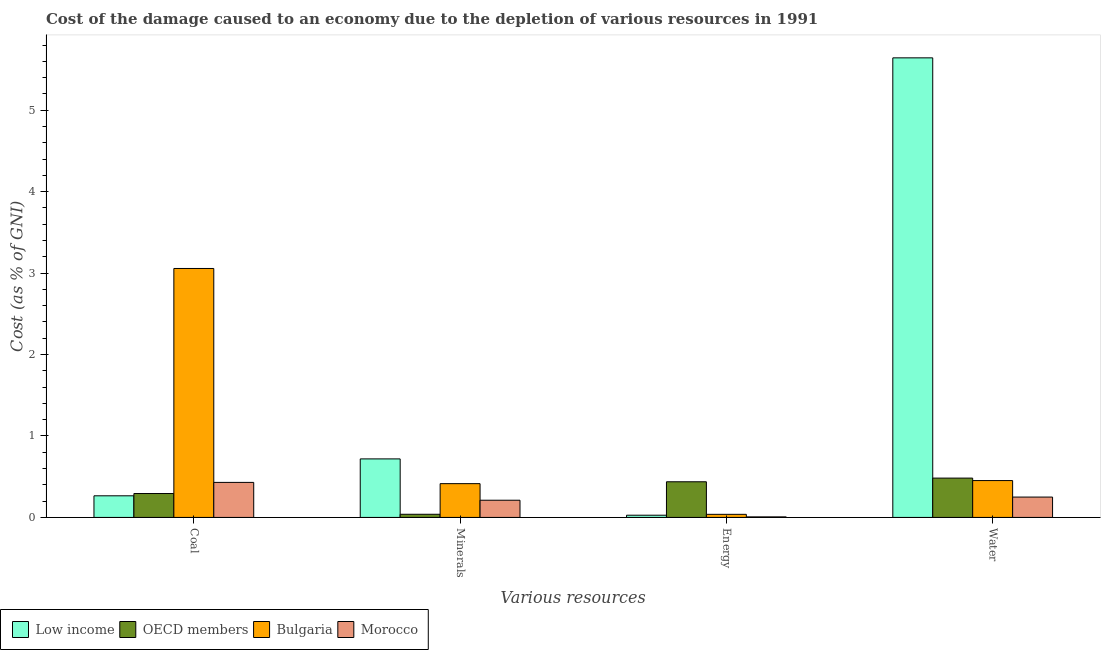How many groups of bars are there?
Give a very brief answer. 4. Are the number of bars per tick equal to the number of legend labels?
Provide a short and direct response. Yes. Are the number of bars on each tick of the X-axis equal?
Keep it short and to the point. Yes. How many bars are there on the 2nd tick from the left?
Provide a short and direct response. 4. What is the label of the 2nd group of bars from the left?
Make the answer very short. Minerals. What is the cost of damage due to depletion of energy in Bulgaria?
Provide a short and direct response. 0.04. Across all countries, what is the maximum cost of damage due to depletion of energy?
Make the answer very short. 0.44. Across all countries, what is the minimum cost of damage due to depletion of minerals?
Your answer should be very brief. 0.04. In which country was the cost of damage due to depletion of energy maximum?
Provide a short and direct response. OECD members. What is the total cost of damage due to depletion of coal in the graph?
Ensure brevity in your answer.  4.05. What is the difference between the cost of damage due to depletion of coal in OECD members and that in Bulgaria?
Give a very brief answer. -2.76. What is the difference between the cost of damage due to depletion of coal in Low income and the cost of damage due to depletion of water in Morocco?
Provide a short and direct response. 0.02. What is the average cost of damage due to depletion of energy per country?
Keep it short and to the point. 0.13. What is the difference between the cost of damage due to depletion of energy and cost of damage due to depletion of water in Morocco?
Offer a very short reply. -0.24. What is the ratio of the cost of damage due to depletion of minerals in Morocco to that in OECD members?
Offer a terse response. 5.46. Is the cost of damage due to depletion of minerals in OECD members less than that in Morocco?
Provide a succinct answer. Yes. What is the difference between the highest and the second highest cost of damage due to depletion of energy?
Your answer should be compact. 0.4. What is the difference between the highest and the lowest cost of damage due to depletion of energy?
Offer a very short reply. 0.43. Is the sum of the cost of damage due to depletion of energy in Low income and Bulgaria greater than the maximum cost of damage due to depletion of coal across all countries?
Give a very brief answer. No. What does the 4th bar from the left in Water represents?
Give a very brief answer. Morocco. What does the 2nd bar from the right in Coal represents?
Offer a very short reply. Bulgaria. Is it the case that in every country, the sum of the cost of damage due to depletion of coal and cost of damage due to depletion of minerals is greater than the cost of damage due to depletion of energy?
Make the answer very short. No. How many bars are there?
Make the answer very short. 16. How many countries are there in the graph?
Provide a succinct answer. 4. What is the difference between two consecutive major ticks on the Y-axis?
Make the answer very short. 1. Are the values on the major ticks of Y-axis written in scientific E-notation?
Ensure brevity in your answer.  No. How many legend labels are there?
Give a very brief answer. 4. How are the legend labels stacked?
Your answer should be compact. Horizontal. What is the title of the graph?
Your response must be concise. Cost of the damage caused to an economy due to the depletion of various resources in 1991 . What is the label or title of the X-axis?
Ensure brevity in your answer.  Various resources. What is the label or title of the Y-axis?
Make the answer very short. Cost (as % of GNI). What is the Cost (as % of GNI) in Low income in Coal?
Provide a short and direct response. 0.27. What is the Cost (as % of GNI) in OECD members in Coal?
Make the answer very short. 0.29. What is the Cost (as % of GNI) of Bulgaria in Coal?
Provide a succinct answer. 3.06. What is the Cost (as % of GNI) of Morocco in Coal?
Offer a very short reply. 0.43. What is the Cost (as % of GNI) of Low income in Minerals?
Offer a terse response. 0.72. What is the Cost (as % of GNI) of OECD members in Minerals?
Offer a very short reply. 0.04. What is the Cost (as % of GNI) of Bulgaria in Minerals?
Keep it short and to the point. 0.41. What is the Cost (as % of GNI) in Morocco in Minerals?
Give a very brief answer. 0.21. What is the Cost (as % of GNI) of Low income in Energy?
Your answer should be very brief. 0.03. What is the Cost (as % of GNI) of OECD members in Energy?
Offer a very short reply. 0.44. What is the Cost (as % of GNI) in Bulgaria in Energy?
Your answer should be compact. 0.04. What is the Cost (as % of GNI) of Morocco in Energy?
Your answer should be very brief. 0.01. What is the Cost (as % of GNI) of Low income in Water?
Keep it short and to the point. 5.64. What is the Cost (as % of GNI) of OECD members in Water?
Your answer should be compact. 0.48. What is the Cost (as % of GNI) in Bulgaria in Water?
Provide a succinct answer. 0.45. What is the Cost (as % of GNI) of Morocco in Water?
Ensure brevity in your answer.  0.25. Across all Various resources, what is the maximum Cost (as % of GNI) of Low income?
Provide a succinct answer. 5.64. Across all Various resources, what is the maximum Cost (as % of GNI) of OECD members?
Give a very brief answer. 0.48. Across all Various resources, what is the maximum Cost (as % of GNI) of Bulgaria?
Ensure brevity in your answer.  3.06. Across all Various resources, what is the maximum Cost (as % of GNI) in Morocco?
Your answer should be compact. 0.43. Across all Various resources, what is the minimum Cost (as % of GNI) in Low income?
Offer a terse response. 0.03. Across all Various resources, what is the minimum Cost (as % of GNI) in OECD members?
Provide a short and direct response. 0.04. Across all Various resources, what is the minimum Cost (as % of GNI) of Bulgaria?
Keep it short and to the point. 0.04. Across all Various resources, what is the minimum Cost (as % of GNI) of Morocco?
Give a very brief answer. 0.01. What is the total Cost (as % of GNI) in Low income in the graph?
Your answer should be compact. 6.65. What is the total Cost (as % of GNI) in OECD members in the graph?
Ensure brevity in your answer.  1.25. What is the total Cost (as % of GNI) in Bulgaria in the graph?
Your answer should be very brief. 3.96. What is the total Cost (as % of GNI) in Morocco in the graph?
Provide a succinct answer. 0.9. What is the difference between the Cost (as % of GNI) of Low income in Coal and that in Minerals?
Give a very brief answer. -0.45. What is the difference between the Cost (as % of GNI) of OECD members in Coal and that in Minerals?
Your answer should be compact. 0.25. What is the difference between the Cost (as % of GNI) of Bulgaria in Coal and that in Minerals?
Give a very brief answer. 2.64. What is the difference between the Cost (as % of GNI) of Morocco in Coal and that in Minerals?
Provide a short and direct response. 0.22. What is the difference between the Cost (as % of GNI) in Low income in Coal and that in Energy?
Offer a terse response. 0.24. What is the difference between the Cost (as % of GNI) of OECD members in Coal and that in Energy?
Your answer should be compact. -0.14. What is the difference between the Cost (as % of GNI) in Bulgaria in Coal and that in Energy?
Keep it short and to the point. 3.02. What is the difference between the Cost (as % of GNI) of Morocco in Coal and that in Energy?
Your response must be concise. 0.42. What is the difference between the Cost (as % of GNI) in Low income in Coal and that in Water?
Offer a terse response. -5.38. What is the difference between the Cost (as % of GNI) in OECD members in Coal and that in Water?
Ensure brevity in your answer.  -0.19. What is the difference between the Cost (as % of GNI) of Bulgaria in Coal and that in Water?
Your response must be concise. 2.6. What is the difference between the Cost (as % of GNI) in Morocco in Coal and that in Water?
Keep it short and to the point. 0.18. What is the difference between the Cost (as % of GNI) in Low income in Minerals and that in Energy?
Make the answer very short. 0.69. What is the difference between the Cost (as % of GNI) of OECD members in Minerals and that in Energy?
Offer a terse response. -0.4. What is the difference between the Cost (as % of GNI) in Bulgaria in Minerals and that in Energy?
Provide a short and direct response. 0.38. What is the difference between the Cost (as % of GNI) in Morocco in Minerals and that in Energy?
Provide a short and direct response. 0.2. What is the difference between the Cost (as % of GNI) in Low income in Minerals and that in Water?
Your answer should be compact. -4.92. What is the difference between the Cost (as % of GNI) in OECD members in Minerals and that in Water?
Your answer should be very brief. -0.44. What is the difference between the Cost (as % of GNI) in Bulgaria in Minerals and that in Water?
Keep it short and to the point. -0.04. What is the difference between the Cost (as % of GNI) of Morocco in Minerals and that in Water?
Offer a terse response. -0.04. What is the difference between the Cost (as % of GNI) in Low income in Energy and that in Water?
Your answer should be very brief. -5.62. What is the difference between the Cost (as % of GNI) of OECD members in Energy and that in Water?
Give a very brief answer. -0.05. What is the difference between the Cost (as % of GNI) of Bulgaria in Energy and that in Water?
Your response must be concise. -0.41. What is the difference between the Cost (as % of GNI) in Morocco in Energy and that in Water?
Offer a terse response. -0.24. What is the difference between the Cost (as % of GNI) of Low income in Coal and the Cost (as % of GNI) of OECD members in Minerals?
Keep it short and to the point. 0.23. What is the difference between the Cost (as % of GNI) in Low income in Coal and the Cost (as % of GNI) in Bulgaria in Minerals?
Give a very brief answer. -0.15. What is the difference between the Cost (as % of GNI) in Low income in Coal and the Cost (as % of GNI) in Morocco in Minerals?
Keep it short and to the point. 0.05. What is the difference between the Cost (as % of GNI) in OECD members in Coal and the Cost (as % of GNI) in Bulgaria in Minerals?
Your answer should be very brief. -0.12. What is the difference between the Cost (as % of GNI) in OECD members in Coal and the Cost (as % of GNI) in Morocco in Minerals?
Your answer should be very brief. 0.08. What is the difference between the Cost (as % of GNI) in Bulgaria in Coal and the Cost (as % of GNI) in Morocco in Minerals?
Ensure brevity in your answer.  2.85. What is the difference between the Cost (as % of GNI) of Low income in Coal and the Cost (as % of GNI) of OECD members in Energy?
Your answer should be compact. -0.17. What is the difference between the Cost (as % of GNI) of Low income in Coal and the Cost (as % of GNI) of Bulgaria in Energy?
Keep it short and to the point. 0.23. What is the difference between the Cost (as % of GNI) of Low income in Coal and the Cost (as % of GNI) of Morocco in Energy?
Your answer should be very brief. 0.26. What is the difference between the Cost (as % of GNI) in OECD members in Coal and the Cost (as % of GNI) in Bulgaria in Energy?
Your answer should be compact. 0.26. What is the difference between the Cost (as % of GNI) in OECD members in Coal and the Cost (as % of GNI) in Morocco in Energy?
Give a very brief answer. 0.29. What is the difference between the Cost (as % of GNI) of Bulgaria in Coal and the Cost (as % of GNI) of Morocco in Energy?
Provide a short and direct response. 3.05. What is the difference between the Cost (as % of GNI) of Low income in Coal and the Cost (as % of GNI) of OECD members in Water?
Make the answer very short. -0.22. What is the difference between the Cost (as % of GNI) of Low income in Coal and the Cost (as % of GNI) of Bulgaria in Water?
Make the answer very short. -0.19. What is the difference between the Cost (as % of GNI) in Low income in Coal and the Cost (as % of GNI) in Morocco in Water?
Your answer should be very brief. 0.02. What is the difference between the Cost (as % of GNI) of OECD members in Coal and the Cost (as % of GNI) of Bulgaria in Water?
Provide a short and direct response. -0.16. What is the difference between the Cost (as % of GNI) of OECD members in Coal and the Cost (as % of GNI) of Morocco in Water?
Offer a terse response. 0.04. What is the difference between the Cost (as % of GNI) of Bulgaria in Coal and the Cost (as % of GNI) of Morocco in Water?
Provide a short and direct response. 2.81. What is the difference between the Cost (as % of GNI) of Low income in Minerals and the Cost (as % of GNI) of OECD members in Energy?
Make the answer very short. 0.28. What is the difference between the Cost (as % of GNI) of Low income in Minerals and the Cost (as % of GNI) of Bulgaria in Energy?
Your answer should be very brief. 0.68. What is the difference between the Cost (as % of GNI) of Low income in Minerals and the Cost (as % of GNI) of Morocco in Energy?
Ensure brevity in your answer.  0.71. What is the difference between the Cost (as % of GNI) in OECD members in Minerals and the Cost (as % of GNI) in Bulgaria in Energy?
Keep it short and to the point. 0. What is the difference between the Cost (as % of GNI) in OECD members in Minerals and the Cost (as % of GNI) in Morocco in Energy?
Provide a succinct answer. 0.03. What is the difference between the Cost (as % of GNI) of Bulgaria in Minerals and the Cost (as % of GNI) of Morocco in Energy?
Your response must be concise. 0.41. What is the difference between the Cost (as % of GNI) in Low income in Minerals and the Cost (as % of GNI) in OECD members in Water?
Provide a short and direct response. 0.24. What is the difference between the Cost (as % of GNI) in Low income in Minerals and the Cost (as % of GNI) in Bulgaria in Water?
Offer a very short reply. 0.27. What is the difference between the Cost (as % of GNI) of Low income in Minerals and the Cost (as % of GNI) of Morocco in Water?
Your response must be concise. 0.47. What is the difference between the Cost (as % of GNI) in OECD members in Minerals and the Cost (as % of GNI) in Bulgaria in Water?
Your answer should be compact. -0.41. What is the difference between the Cost (as % of GNI) in OECD members in Minerals and the Cost (as % of GNI) in Morocco in Water?
Make the answer very short. -0.21. What is the difference between the Cost (as % of GNI) of Bulgaria in Minerals and the Cost (as % of GNI) of Morocco in Water?
Offer a terse response. 0.16. What is the difference between the Cost (as % of GNI) in Low income in Energy and the Cost (as % of GNI) in OECD members in Water?
Your response must be concise. -0.46. What is the difference between the Cost (as % of GNI) in Low income in Energy and the Cost (as % of GNI) in Bulgaria in Water?
Offer a very short reply. -0.43. What is the difference between the Cost (as % of GNI) in Low income in Energy and the Cost (as % of GNI) in Morocco in Water?
Provide a short and direct response. -0.22. What is the difference between the Cost (as % of GNI) of OECD members in Energy and the Cost (as % of GNI) of Bulgaria in Water?
Offer a very short reply. -0.01. What is the difference between the Cost (as % of GNI) of OECD members in Energy and the Cost (as % of GNI) of Morocco in Water?
Ensure brevity in your answer.  0.19. What is the difference between the Cost (as % of GNI) of Bulgaria in Energy and the Cost (as % of GNI) of Morocco in Water?
Offer a very short reply. -0.21. What is the average Cost (as % of GNI) in Low income per Various resources?
Offer a terse response. 1.66. What is the average Cost (as % of GNI) of OECD members per Various resources?
Your answer should be compact. 0.31. What is the average Cost (as % of GNI) in Bulgaria per Various resources?
Provide a short and direct response. 0.99. What is the average Cost (as % of GNI) in Morocco per Various resources?
Make the answer very short. 0.22. What is the difference between the Cost (as % of GNI) in Low income and Cost (as % of GNI) in OECD members in Coal?
Provide a short and direct response. -0.03. What is the difference between the Cost (as % of GNI) in Low income and Cost (as % of GNI) in Bulgaria in Coal?
Your response must be concise. -2.79. What is the difference between the Cost (as % of GNI) of Low income and Cost (as % of GNI) of Morocco in Coal?
Your answer should be compact. -0.16. What is the difference between the Cost (as % of GNI) of OECD members and Cost (as % of GNI) of Bulgaria in Coal?
Provide a succinct answer. -2.76. What is the difference between the Cost (as % of GNI) of OECD members and Cost (as % of GNI) of Morocco in Coal?
Give a very brief answer. -0.14. What is the difference between the Cost (as % of GNI) in Bulgaria and Cost (as % of GNI) in Morocco in Coal?
Keep it short and to the point. 2.63. What is the difference between the Cost (as % of GNI) in Low income and Cost (as % of GNI) in OECD members in Minerals?
Offer a very short reply. 0.68. What is the difference between the Cost (as % of GNI) of Low income and Cost (as % of GNI) of Bulgaria in Minerals?
Your answer should be compact. 0.3. What is the difference between the Cost (as % of GNI) of Low income and Cost (as % of GNI) of Morocco in Minerals?
Keep it short and to the point. 0.51. What is the difference between the Cost (as % of GNI) of OECD members and Cost (as % of GNI) of Bulgaria in Minerals?
Provide a short and direct response. -0.38. What is the difference between the Cost (as % of GNI) of OECD members and Cost (as % of GNI) of Morocco in Minerals?
Your answer should be very brief. -0.17. What is the difference between the Cost (as % of GNI) in Bulgaria and Cost (as % of GNI) in Morocco in Minerals?
Your response must be concise. 0.2. What is the difference between the Cost (as % of GNI) of Low income and Cost (as % of GNI) of OECD members in Energy?
Make the answer very short. -0.41. What is the difference between the Cost (as % of GNI) of Low income and Cost (as % of GNI) of Bulgaria in Energy?
Provide a short and direct response. -0.01. What is the difference between the Cost (as % of GNI) in Low income and Cost (as % of GNI) in Morocco in Energy?
Provide a succinct answer. 0.02. What is the difference between the Cost (as % of GNI) of OECD members and Cost (as % of GNI) of Bulgaria in Energy?
Your answer should be compact. 0.4. What is the difference between the Cost (as % of GNI) in OECD members and Cost (as % of GNI) in Morocco in Energy?
Make the answer very short. 0.43. What is the difference between the Cost (as % of GNI) in Bulgaria and Cost (as % of GNI) in Morocco in Energy?
Your answer should be very brief. 0.03. What is the difference between the Cost (as % of GNI) in Low income and Cost (as % of GNI) in OECD members in Water?
Give a very brief answer. 5.16. What is the difference between the Cost (as % of GNI) in Low income and Cost (as % of GNI) in Bulgaria in Water?
Offer a very short reply. 5.19. What is the difference between the Cost (as % of GNI) in Low income and Cost (as % of GNI) in Morocco in Water?
Your response must be concise. 5.39. What is the difference between the Cost (as % of GNI) in OECD members and Cost (as % of GNI) in Bulgaria in Water?
Ensure brevity in your answer.  0.03. What is the difference between the Cost (as % of GNI) of OECD members and Cost (as % of GNI) of Morocco in Water?
Offer a very short reply. 0.23. What is the difference between the Cost (as % of GNI) of Bulgaria and Cost (as % of GNI) of Morocco in Water?
Offer a terse response. 0.2. What is the ratio of the Cost (as % of GNI) in Low income in Coal to that in Minerals?
Ensure brevity in your answer.  0.37. What is the ratio of the Cost (as % of GNI) of OECD members in Coal to that in Minerals?
Offer a very short reply. 7.59. What is the ratio of the Cost (as % of GNI) of Bulgaria in Coal to that in Minerals?
Your response must be concise. 7.37. What is the ratio of the Cost (as % of GNI) of Morocco in Coal to that in Minerals?
Provide a succinct answer. 2.04. What is the ratio of the Cost (as % of GNI) of Low income in Coal to that in Energy?
Offer a very short reply. 9.79. What is the ratio of the Cost (as % of GNI) of OECD members in Coal to that in Energy?
Provide a succinct answer. 0.67. What is the ratio of the Cost (as % of GNI) of Bulgaria in Coal to that in Energy?
Provide a succinct answer. 80.66. What is the ratio of the Cost (as % of GNI) of Morocco in Coal to that in Energy?
Ensure brevity in your answer.  64.43. What is the ratio of the Cost (as % of GNI) in Low income in Coal to that in Water?
Provide a short and direct response. 0.05. What is the ratio of the Cost (as % of GNI) in OECD members in Coal to that in Water?
Make the answer very short. 0.61. What is the ratio of the Cost (as % of GNI) in Bulgaria in Coal to that in Water?
Ensure brevity in your answer.  6.75. What is the ratio of the Cost (as % of GNI) in Morocco in Coal to that in Water?
Provide a short and direct response. 1.72. What is the ratio of the Cost (as % of GNI) of Low income in Minerals to that in Energy?
Provide a short and direct response. 26.51. What is the ratio of the Cost (as % of GNI) in OECD members in Minerals to that in Energy?
Give a very brief answer. 0.09. What is the ratio of the Cost (as % of GNI) in Bulgaria in Minerals to that in Energy?
Your answer should be compact. 10.94. What is the ratio of the Cost (as % of GNI) of Morocco in Minerals to that in Energy?
Offer a terse response. 31.63. What is the ratio of the Cost (as % of GNI) of Low income in Minerals to that in Water?
Your answer should be compact. 0.13. What is the ratio of the Cost (as % of GNI) in OECD members in Minerals to that in Water?
Offer a very short reply. 0.08. What is the ratio of the Cost (as % of GNI) of Bulgaria in Minerals to that in Water?
Your response must be concise. 0.92. What is the ratio of the Cost (as % of GNI) of Morocco in Minerals to that in Water?
Provide a succinct answer. 0.84. What is the ratio of the Cost (as % of GNI) of Low income in Energy to that in Water?
Ensure brevity in your answer.  0. What is the ratio of the Cost (as % of GNI) in OECD members in Energy to that in Water?
Your answer should be very brief. 0.91. What is the ratio of the Cost (as % of GNI) of Bulgaria in Energy to that in Water?
Ensure brevity in your answer.  0.08. What is the ratio of the Cost (as % of GNI) of Morocco in Energy to that in Water?
Make the answer very short. 0.03. What is the difference between the highest and the second highest Cost (as % of GNI) in Low income?
Offer a terse response. 4.92. What is the difference between the highest and the second highest Cost (as % of GNI) of OECD members?
Provide a short and direct response. 0.05. What is the difference between the highest and the second highest Cost (as % of GNI) of Bulgaria?
Give a very brief answer. 2.6. What is the difference between the highest and the second highest Cost (as % of GNI) of Morocco?
Offer a terse response. 0.18. What is the difference between the highest and the lowest Cost (as % of GNI) in Low income?
Your response must be concise. 5.62. What is the difference between the highest and the lowest Cost (as % of GNI) of OECD members?
Keep it short and to the point. 0.44. What is the difference between the highest and the lowest Cost (as % of GNI) of Bulgaria?
Your response must be concise. 3.02. What is the difference between the highest and the lowest Cost (as % of GNI) in Morocco?
Offer a terse response. 0.42. 